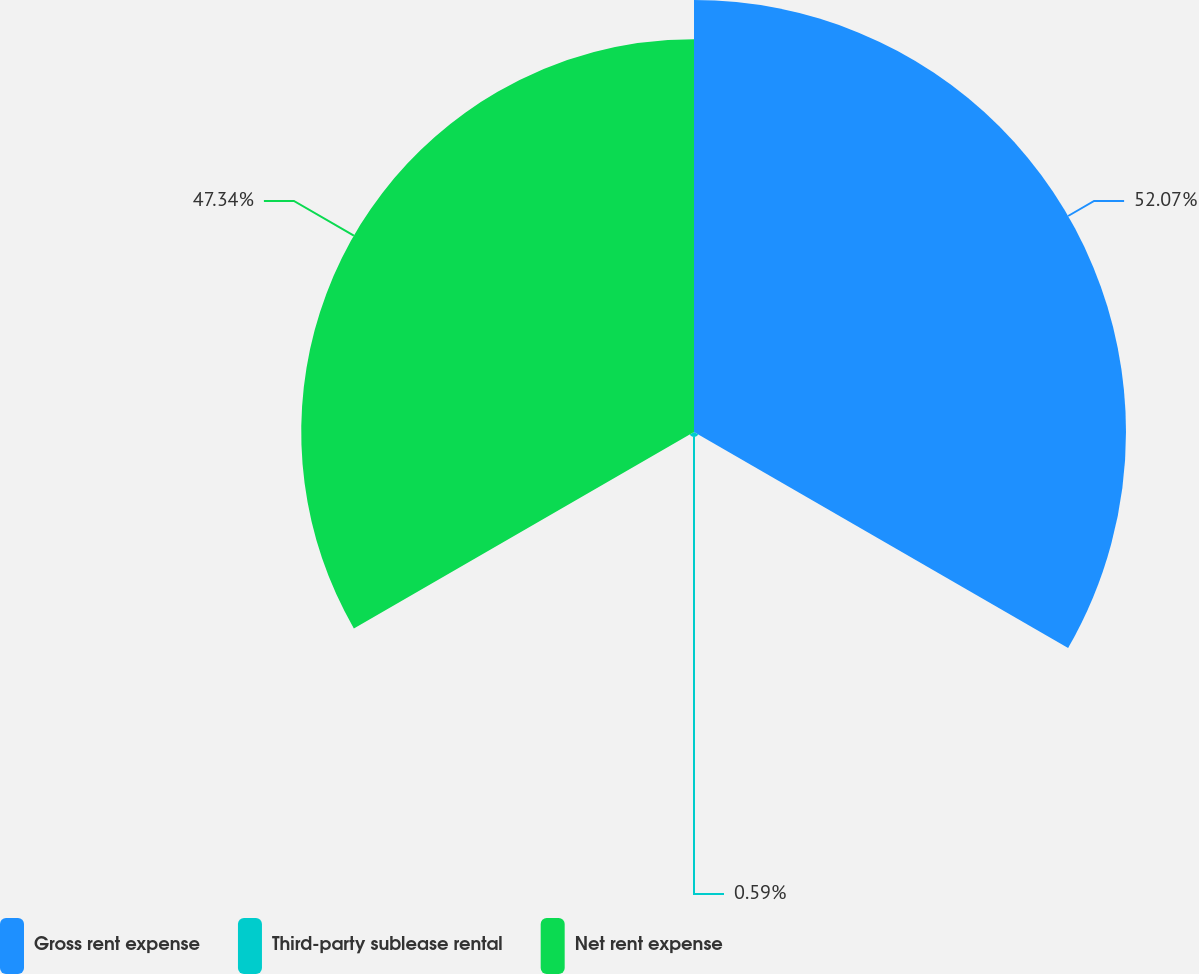Convert chart to OTSL. <chart><loc_0><loc_0><loc_500><loc_500><pie_chart><fcel>Gross rent expense<fcel>Third-party sublease rental<fcel>Net rent expense<nl><fcel>52.07%<fcel>0.59%<fcel>47.34%<nl></chart> 